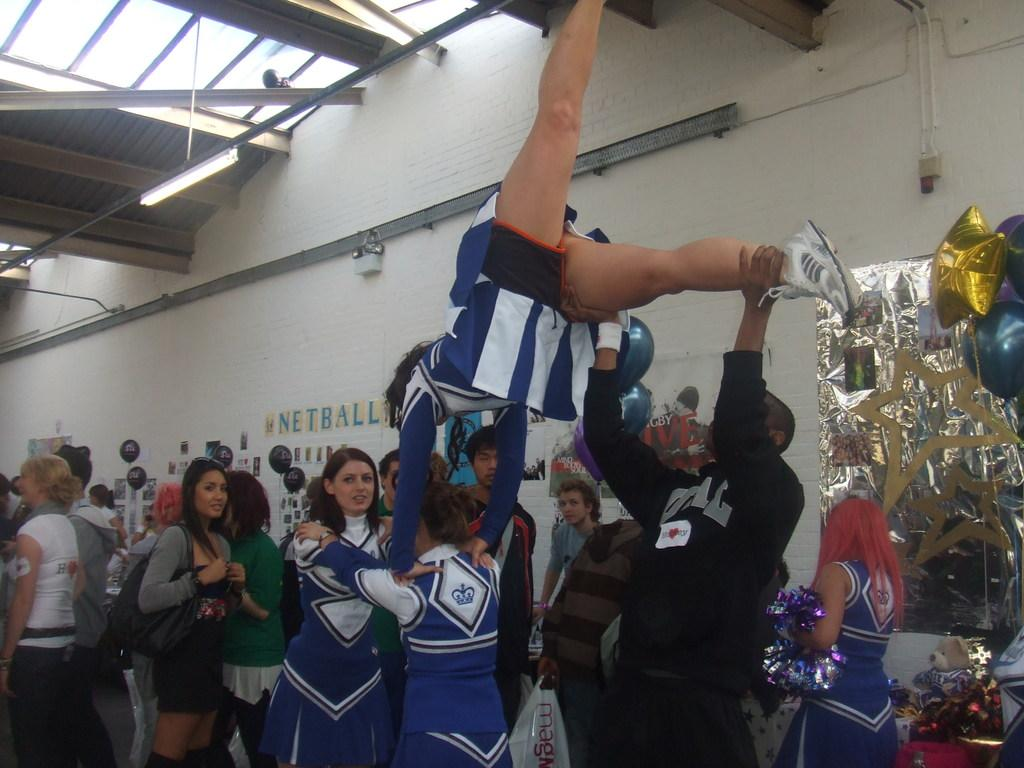<image>
Create a compact narrative representing the image presented. Cheerleaders perform a routine indoors in front of a netball sign. 